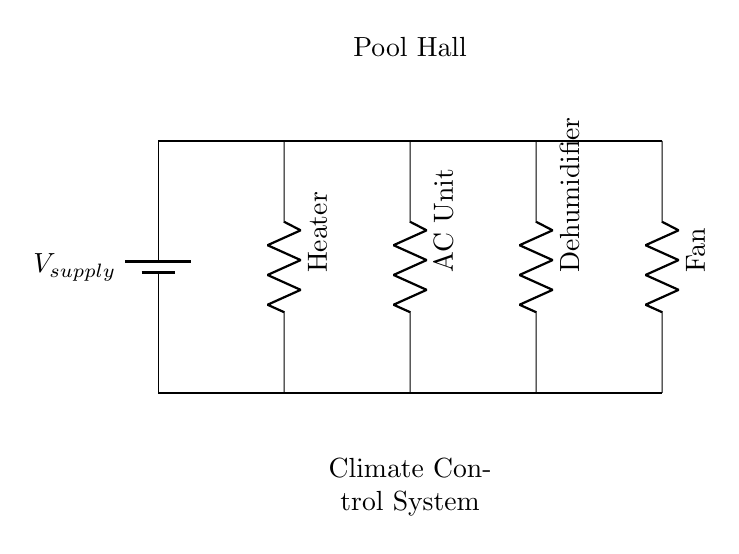What components are in the circuit? The circuit includes a heater, an AC unit, a dehumidifier, and a fan, which are the resistive loads connected in parallel.
Answer: heater, AC unit, dehumidifier, fan How many resistive loads are present? There are four resistive loads: the heater, AC unit, dehumidifier, and fan. It can be counted directly from the diagram.
Answer: four What is the function of the AC unit in this circuit? The AC unit's function is to cool the air, regulating temperature in the pool hall, which is essential for maintaining a comfortable environment for pool players.
Answer: cool air What is the configuration of the circuit? The circuit is configured in a parallel arrangement, meaning that all components share the same voltage supply but can operate independently.
Answer: parallel How does the parallel configuration affect current flow? In a parallel circuit, the total current entering a junction is equal to the sum of the currents through each parallel branch, allowing for independent operation and ensuring that if one component fails, others remain functional.
Answer: independent operation 